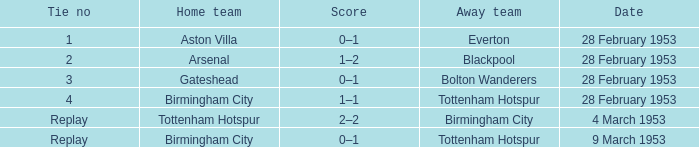Which Home team has a Score of 0–1, and an Away team of tottenham hotspur? Birmingham City. 